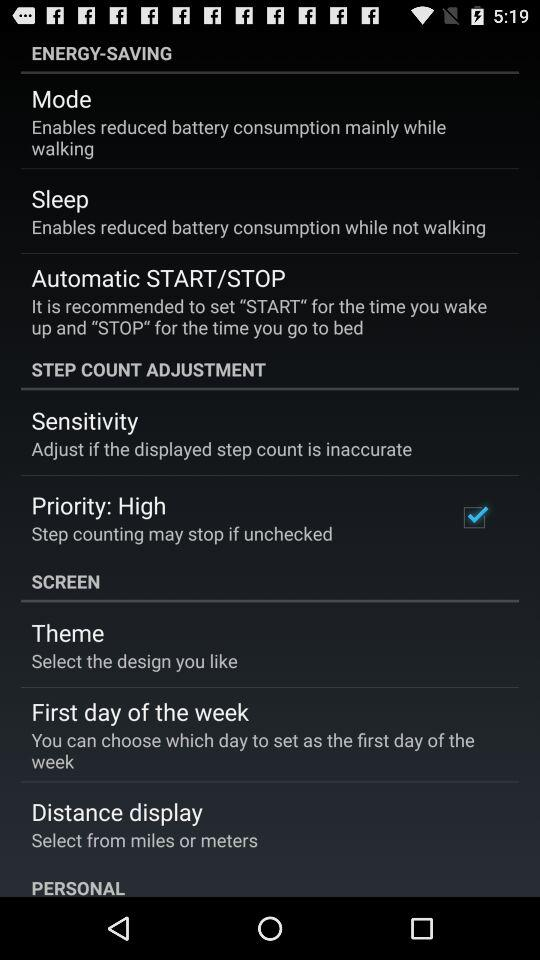Which option was selected? The selected option was "Priority: High". 